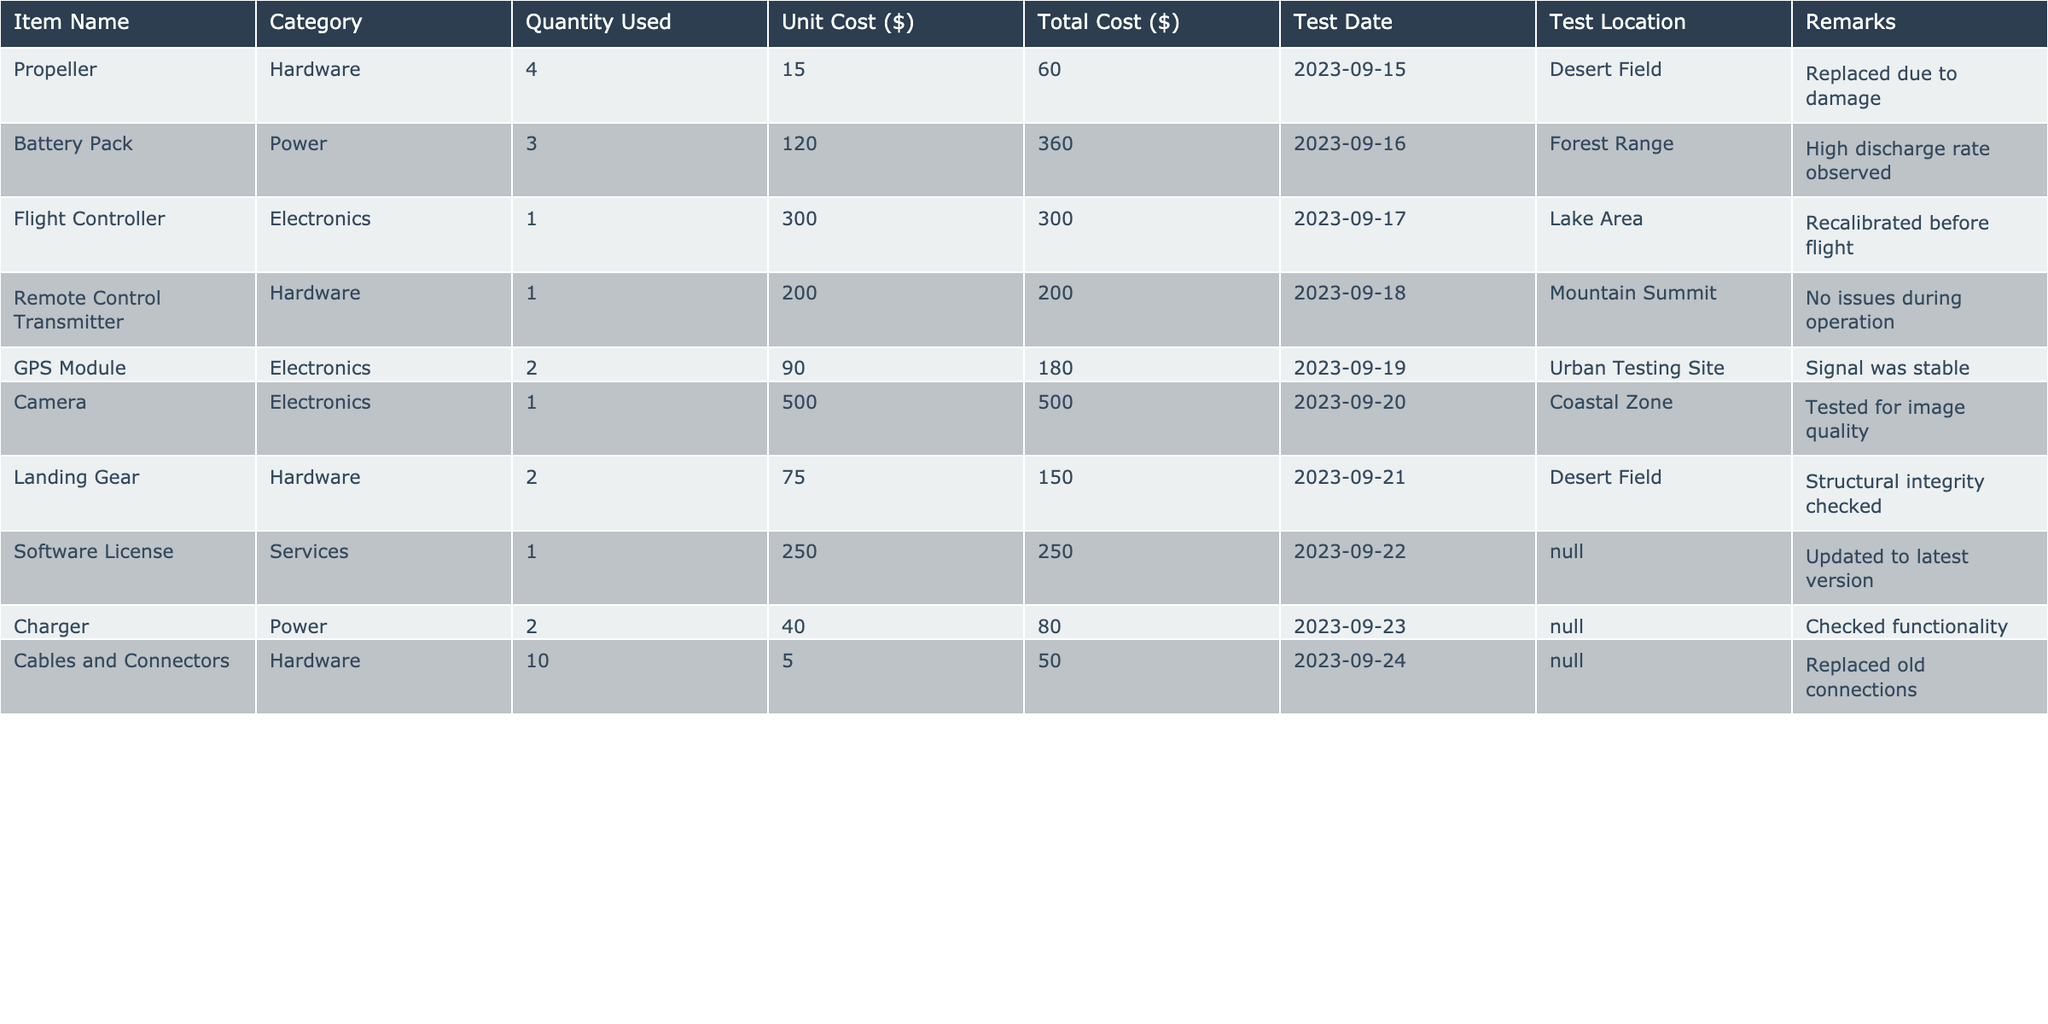What is the total cost of the Battery Pack? The total cost for each item can be found in the "Total Cost ($)" column. For the Battery Pack, the total cost is directly listed as 360.00.
Answer: 360.00 How many items from the Hardware category were consumed? To find the total number of items from the Hardware category, we can count the occurrences in the "Category" column. There are three items listed under Hardware: Propeller, Remote Control Transmitter, and Landing Gear, so the total is 3.
Answer: 3 Which item had the highest unit cost and what was it? To determine the item with the highest unit cost, we check the "Unit Cost ($)" column. The item with the highest value is the Camera, which costs 500.00.
Answer: Camera, 500.00 What is the average total cost of the consumed inventory? First, we sum the total costs from the "Total Cost ($)" column: 60 + 360 + 300 + 200 + 180 + 500 + 150 + 250 + 80 + 50 = 1930. There are 10 items, so the average total cost is 1930/10 = 193.0.
Answer: 193.0 Did any item require replacement due to damage, and if so, which one? By reviewing the "Remarks" column, we see that the Propeller was replaced due to damage. Therefore, yes, there was an item that required replacement.
Answer: Yes, Propeller What is the total quantity used of all electronics combined? To find the total quantity used for electronics, we focus on the rows categorized as Electronics: Flight Controller (1), GPS Module (2), Camera (1). Adding these gives us: 1 + 2 + 1 = 4.
Answer: 4 Was there any item whose quantity used was greater than 2? We inspect the "Quantity Used" column. The only items with a quantity greater than 2 are the Battery Pack (3) and Cables and Connectors (10). Therefore, the answer is yes.
Answer: Yes What was the total amount spent on Power category items? For the Power category, we consider the Battery Pack (360.00) and Charger (80.00). Summing these totals gives: 360.00 + 80.00 = 440.00.
Answer: 440.00 Which test location had the most items consumed? By analyzing the "Test Location" column, we see that the Desert Field has two items listed: Propeller and Landing Gear. Compared to other locations, which each have one item, Desert Field has consumed the most items.
Answer: Desert Field 